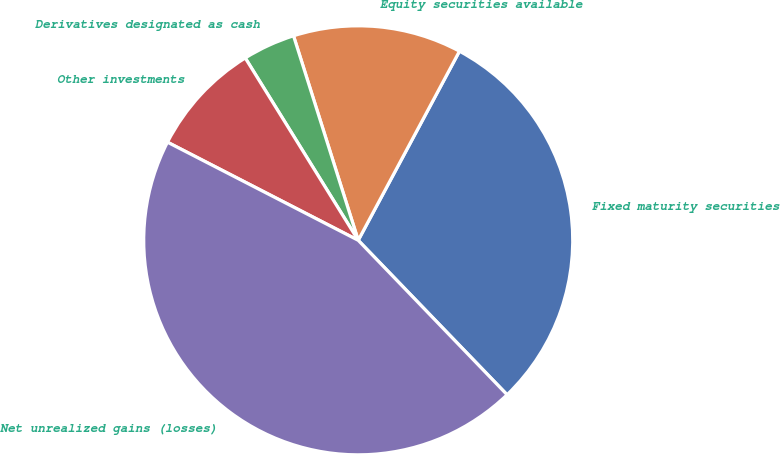<chart> <loc_0><loc_0><loc_500><loc_500><pie_chart><fcel>Fixed maturity securities<fcel>Equity securities available<fcel>Derivatives designated as cash<fcel>Other investments<fcel>Net unrealized gains (losses)<nl><fcel>29.97%<fcel>12.7%<fcel>3.95%<fcel>8.61%<fcel>44.77%<nl></chart> 